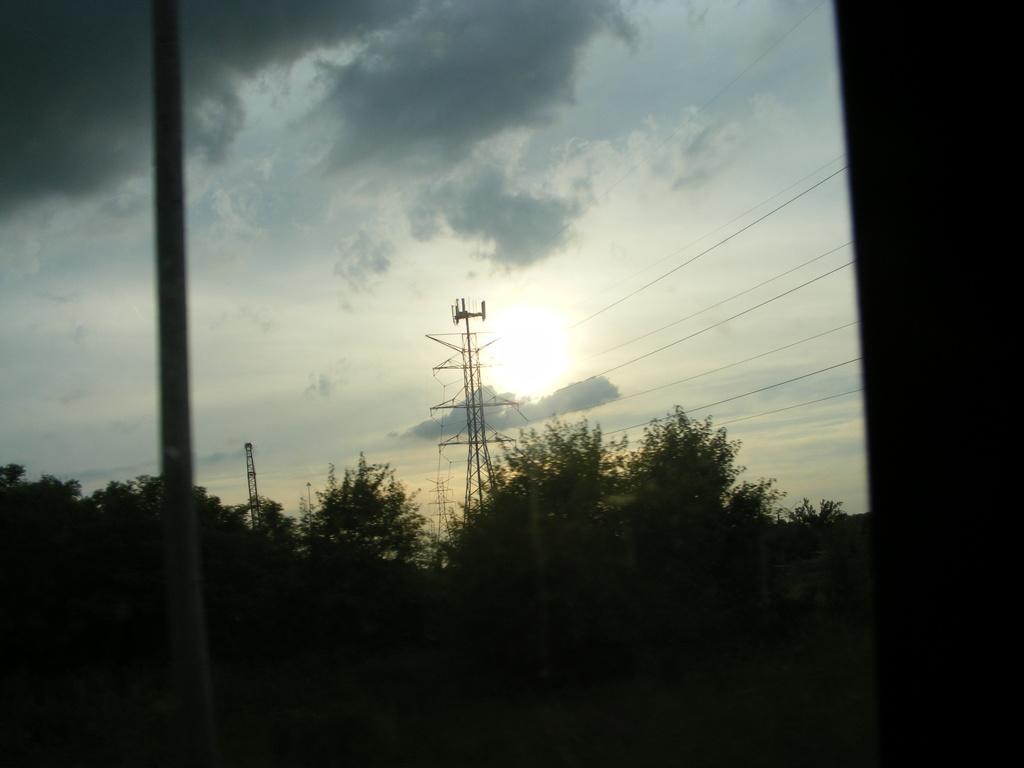In one or two sentences, can you explain what this image depicts? In this image we can see few trees, pole, towers with wires and the sky with clouds and sun in the background. 